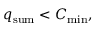<formula> <loc_0><loc_0><loc_500><loc_500>q _ { s u m } < C _ { \min } ,</formula> 